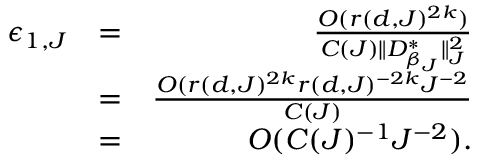Convert formula to latex. <formula><loc_0><loc_0><loc_500><loc_500>\begin{array} { r l r } { \epsilon _ { 1 , J } } & { = } & { \frac { O ( r ( d , J ) ^ { 2 k } ) } { C ( J ) \| D _ { \beta _ { J } } ^ { * } \| _ { J } ^ { 2 } } } \\ & { = } & { \frac { O ( r ( d , J ) ^ { 2 k } r ( d , J ) ^ { - 2 k } J ^ { - 2 } } { C ( J ) } } \\ & { = } & { O ( C ( J ) ^ { - 1 } J ^ { - 2 } ) . } \end{array}</formula> 